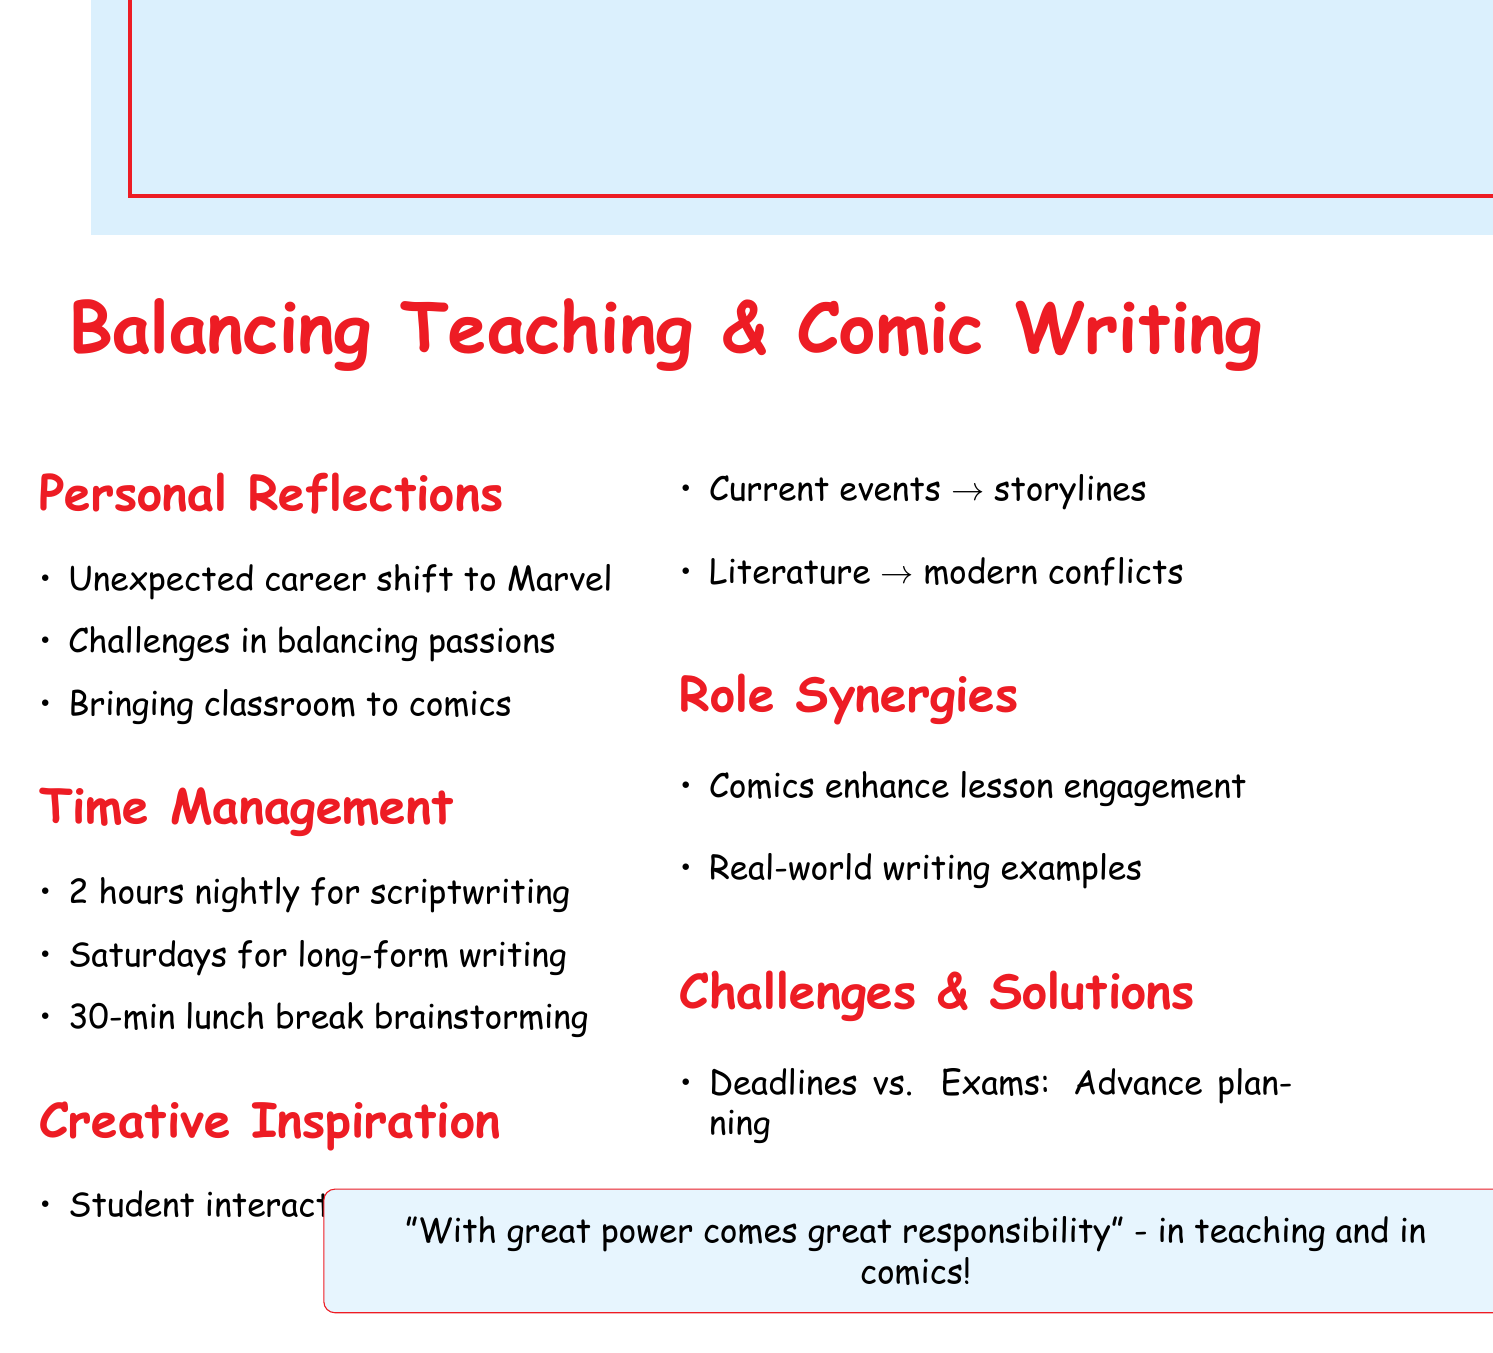What is the main title of the document? The title of the document is presented in the center as the main headline.
Answer: Balancing Teaching & Comic Writing How much time is allocated every evening for scriptwriting? The specific time allocation for scriptwriting in the evenings is listed in the time management section.
Answer: 2 hours What day is dedicated for long-form writing sessions? The document specifies which day of the week is set aside for intensive writing.
Answer: Saturdays Which example is given for student interactions as a source of inspiration? An example related to student interactions is provided in the creative inspiration section.
Answer: Basing a new teenage superhero on the resilience of a struggling student What is one challenge faced during exam seasons? The document outlines specific challenges that arise during certain periods, including the exam season.
Answer: Meeting Marvel deadlines How does the document suggest maintaining work-life balance? The solutions provided in the challenges section addresses how to maintain a healthy balance between work and personal life.
Answer: Clear boundaries What type of writing is impacted positively by comic writing experience? This refers to the benefit noted in the synergies section regarding the experience from comic writing.
Answer: Enhanced student engagement What literature is referenced for adapting themes? The document highlights specific literature that influences the writing of superhero narratives.
Answer: Shakespeare 